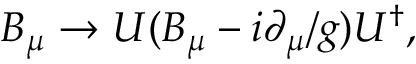Convert formula to latex. <formula><loc_0><loc_0><loc_500><loc_500>B _ { \mu } \rightarrow U ( B _ { \mu } - i \partial _ { \mu } / g ) U ^ { \dagger } ,</formula> 